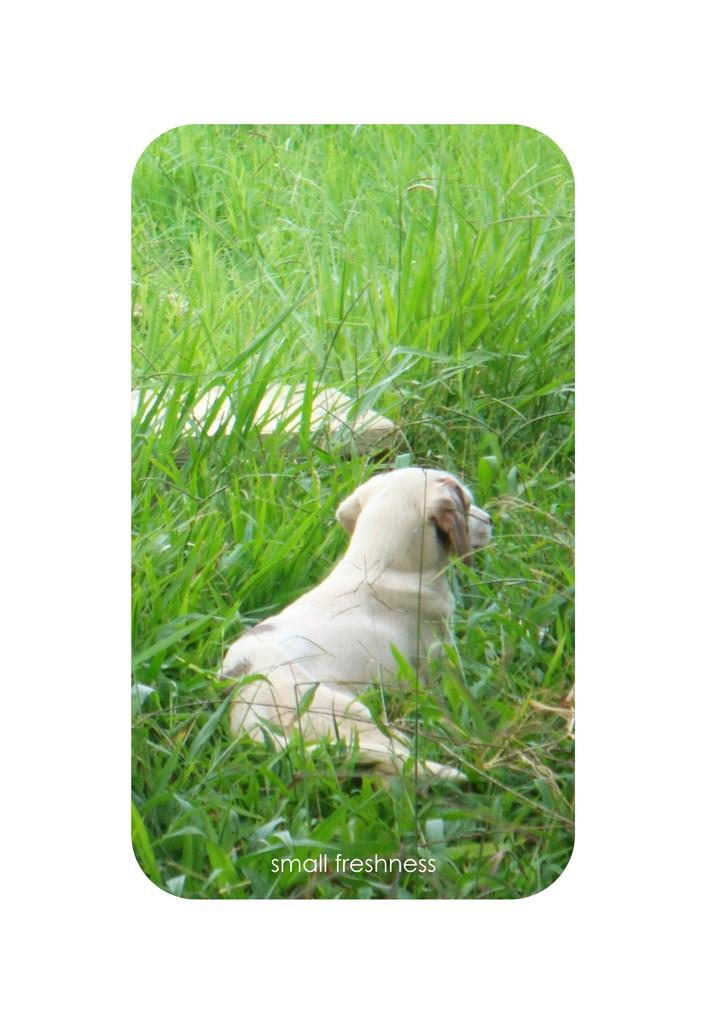What animal can be seen in the image? There is a puppy in the image. Where is the puppy located? The puppy is sitting in the grass. What type of treatment does the jar receive from the puppy in the image? There is no jar present in the image, so it is not possible to answer that question. 